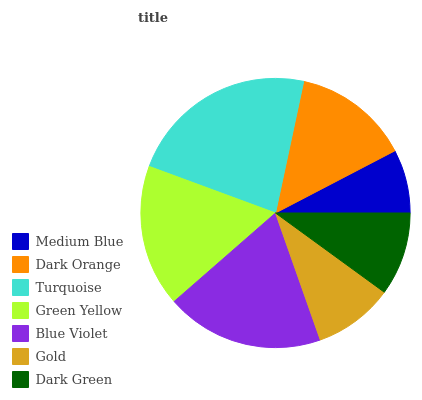Is Medium Blue the minimum?
Answer yes or no. Yes. Is Turquoise the maximum?
Answer yes or no. Yes. Is Dark Orange the minimum?
Answer yes or no. No. Is Dark Orange the maximum?
Answer yes or no. No. Is Dark Orange greater than Medium Blue?
Answer yes or no. Yes. Is Medium Blue less than Dark Orange?
Answer yes or no. Yes. Is Medium Blue greater than Dark Orange?
Answer yes or no. No. Is Dark Orange less than Medium Blue?
Answer yes or no. No. Is Dark Orange the high median?
Answer yes or no. Yes. Is Dark Orange the low median?
Answer yes or no. Yes. Is Blue Violet the high median?
Answer yes or no. No. Is Turquoise the low median?
Answer yes or no. No. 